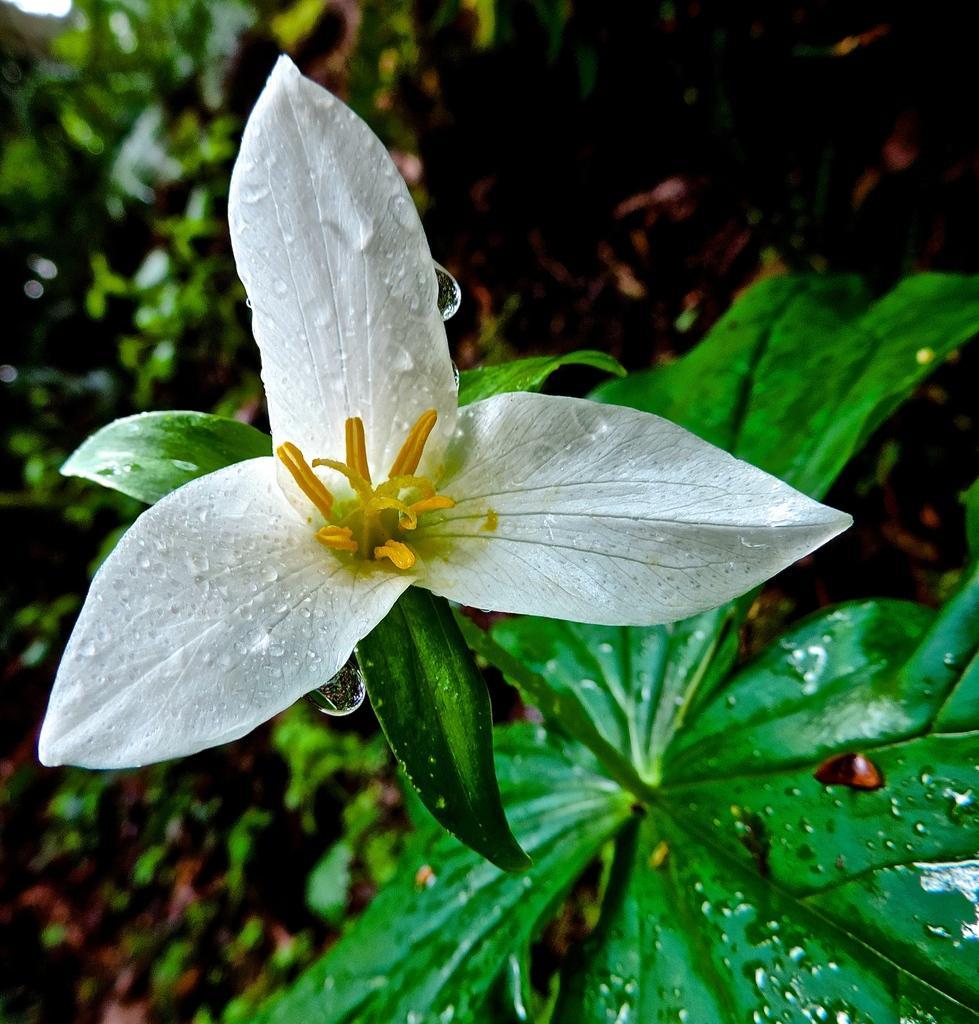Please provide a concise description of this image. In this image we can see one plant with one white flower, some plants and dried leaves on the ground in the background. The background is dark. 